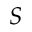Convert formula to latex. <formula><loc_0><loc_0><loc_500><loc_500>S</formula> 